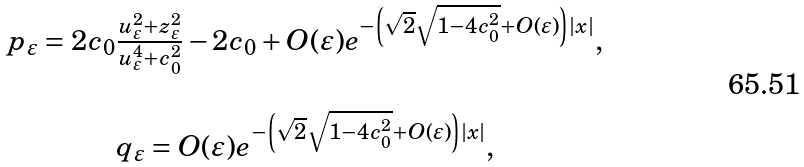Convert formula to latex. <formula><loc_0><loc_0><loc_500><loc_500>\begin{array} { c } p _ { \varepsilon } = 2 c _ { 0 } \frac { u _ { \varepsilon } ^ { 2 } + z _ { \varepsilon } ^ { 2 } } { u _ { \varepsilon } ^ { 4 } + c _ { 0 } ^ { 2 } } - 2 c _ { 0 } + O ( \varepsilon ) e ^ { - \left ( \sqrt { 2 } \sqrt { 1 - 4 c _ { 0 } ^ { 2 } } + O ( \varepsilon ) \right ) | x | } , \\ \\ q _ { \varepsilon } = O ( \varepsilon ) e ^ { - \left ( \sqrt { 2 } \sqrt { 1 - 4 c _ { 0 } ^ { 2 } } + O ( \varepsilon ) \right ) | x | } , \end{array}</formula> 